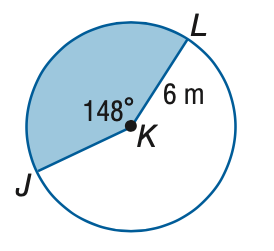Answer the mathemtical geometry problem and directly provide the correct option letter.
Question: Find the area of the shaded sector. Round to the nearest tenth.
Choices: A: 15.5 B: 46.5 C: 66.6 D: 113.1 B 